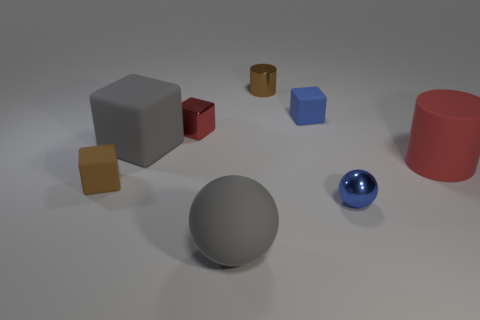The tiny thing that is the same color as the small sphere is what shape?
Keep it short and to the point. Cube. There is a thing that is on the right side of the blue matte thing and in front of the big red cylinder; what is its size?
Your response must be concise. Small. There is a tiny red thing that is the same shape as the brown matte thing; what is its material?
Ensure brevity in your answer.  Metal. There is a red object that is to the right of the blue metallic sphere; is its size the same as the small blue block?
Your answer should be compact. No. The large matte thing that is both behind the brown rubber block and to the left of the tiny metallic sphere is what color?
Your answer should be compact. Gray. There is a large gray object behind the big gray rubber sphere; how many small matte cubes are right of it?
Make the answer very short. 1. Do the red rubber object and the small brown metal object have the same shape?
Your answer should be very brief. Yes. Is there any other thing that has the same color as the shiny cylinder?
Make the answer very short. Yes. There is a brown rubber object; is it the same shape as the blue thing right of the tiny blue matte cube?
Offer a terse response. No. The cylinder to the right of the tiny brown object that is behind the red metallic thing that is on the left side of the tiny blue ball is what color?
Provide a succinct answer. Red. 